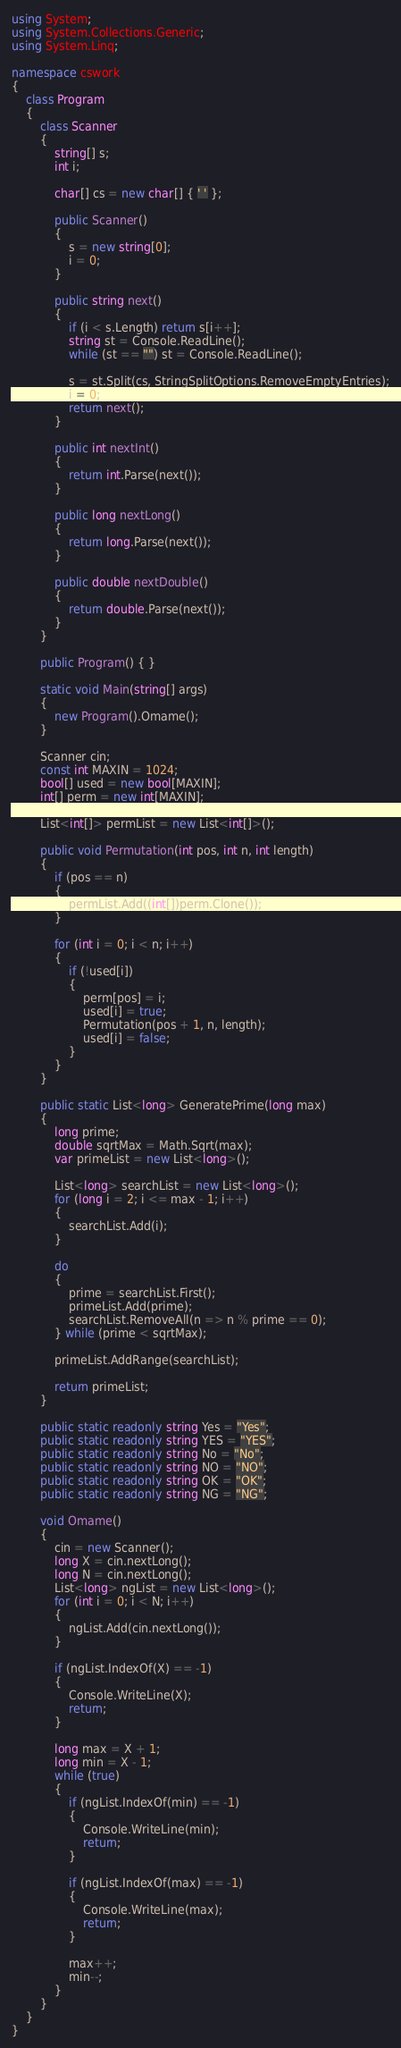Convert code to text. <code><loc_0><loc_0><loc_500><loc_500><_C#_>using System;
using System.Collections.Generic;
using System.Linq;

namespace cswork
{
    class Program
    {
        class Scanner
        {
            string[] s;
            int i;

            char[] cs = new char[] { ' ' };

            public Scanner()
            {
                s = new string[0];
                i = 0;
            }

            public string next()
            {
                if (i < s.Length) return s[i++];
                string st = Console.ReadLine();
                while (st == "") st = Console.ReadLine();

                s = st.Split(cs, StringSplitOptions.RemoveEmptyEntries);
                i = 0;
                return next();
            }

            public int nextInt()
            {
                return int.Parse(next());
            }

            public long nextLong()
            {
                return long.Parse(next());
            }

            public double nextDouble()
            {
                return double.Parse(next());
            }
        }

        public Program() { }

        static void Main(string[] args)
        {
            new Program().Omame();
        }

        Scanner cin;
        const int MAXIN = 1024;
        bool[] used = new bool[MAXIN];
        int[] perm = new int[MAXIN];

        List<int[]> permList = new List<int[]>();

        public void Permutation(int pos, int n, int length)
        {
            if (pos == n)
            {
                permList.Add((int[])perm.Clone());
            }

            for (int i = 0; i < n; i++)
            {
                if (!used[i])
                {
                    perm[pos] = i;
                    used[i] = true;
                    Permutation(pos + 1, n, length);
                    used[i] = false;
                }
            }
        }

        public static List<long> GeneratePrime(long max)
        {
            long prime;
            double sqrtMax = Math.Sqrt(max);
            var primeList = new List<long>();

            List<long> searchList = new List<long>();
            for (long i = 2; i <= max - 1; i++)
            {
                searchList.Add(i);
            }

            do
            {
                prime = searchList.First();
                primeList.Add(prime);
                searchList.RemoveAll(n => n % prime == 0);
            } while (prime < sqrtMax);

            primeList.AddRange(searchList);

            return primeList;
        }

        public static readonly string Yes = "Yes";
        public static readonly string YES = "YES";
        public static readonly string No = "No";
        public static readonly string NO = "NO";
        public static readonly string OK = "OK";
        public static readonly string NG = "NG";

        void Omame()
        {
            cin = new Scanner();
            long X = cin.nextLong();
            long N = cin.nextLong();
            List<long> ngList = new List<long>();
            for (int i = 0; i < N; i++)
            {
                ngList.Add(cin.nextLong());
            }

            if (ngList.IndexOf(X) == -1)
            {
                Console.WriteLine(X);
                return;
            }

            long max = X + 1;
            long min = X - 1;
            while (true)
            {
                if (ngList.IndexOf(min) == -1)
                {
                    Console.WriteLine(min);
                    return;
                }

                if (ngList.IndexOf(max) == -1)
                {
                    Console.WriteLine(max);
                    return;
                }

                max++;
                min--;
            }
        }
    }
}
</code> 